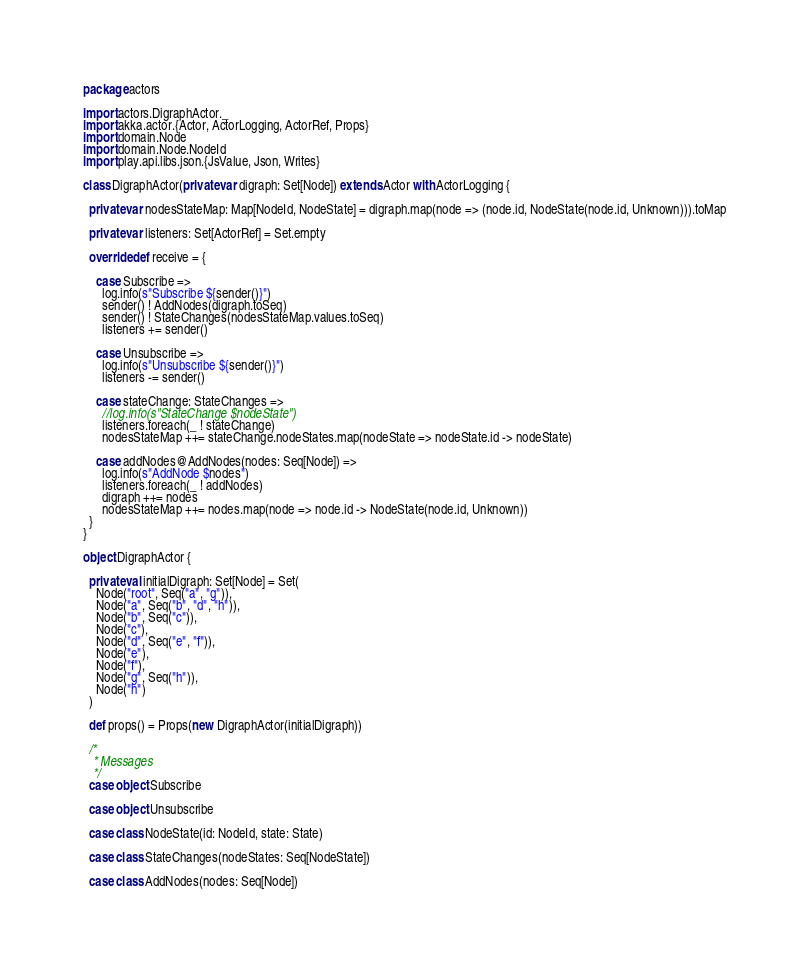<code> <loc_0><loc_0><loc_500><loc_500><_Scala_>package actors

import actors.DigraphActor._
import akka.actor.{Actor, ActorLogging, ActorRef, Props}
import domain.Node
import domain.Node.NodeId
import play.api.libs.json.{JsValue, Json, Writes}

class DigraphActor(private var digraph: Set[Node]) extends Actor with ActorLogging {

  private var nodesStateMap: Map[NodeId, NodeState] = digraph.map(node => (node.id, NodeState(node.id, Unknown))).toMap

  private var listeners: Set[ActorRef] = Set.empty

  override def receive = {

    case Subscribe =>
      log.info(s"Subscribe ${sender()}")
      sender() ! AddNodes(digraph.toSeq)
      sender() ! StateChanges(nodesStateMap.values.toSeq)
      listeners += sender()

    case Unsubscribe =>
      log.info(s"Unsubscribe ${sender()}")
      listeners -= sender()

    case stateChange: StateChanges =>
      //log.info(s"StateChange $nodeState")
      listeners.foreach(_ ! stateChange)
      nodesStateMap ++= stateChange.nodeStates.map(nodeState => nodeState.id -> nodeState)

    case addNodes@AddNodes(nodes: Seq[Node]) =>
      log.info(s"AddNode $nodes")
      listeners.foreach(_ ! addNodes)
      digraph ++= nodes
      nodesStateMap ++= nodes.map(node => node.id -> NodeState(node.id, Unknown))
  }
}

object DigraphActor {

  private val initialDigraph: Set[Node] = Set(
    Node("root", Seq("a", "g")),
    Node("a", Seq("b", "d", "h")),
    Node("b", Seq("c")),
    Node("c"),
    Node("d", Seq("e", "f")),
    Node("e"),
    Node("f"),
    Node("g", Seq("h")),
    Node("h")
  )

  def props() = Props(new DigraphActor(initialDigraph))

  /*
   * Messages
   */
  case object Subscribe

  case object Unsubscribe

  case class NodeState(id: NodeId, state: State)

  case class StateChanges(nodeStates: Seq[NodeState])

  case class AddNodes(nodes: Seq[Node])

</code> 